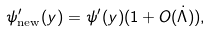Convert formula to latex. <formula><loc_0><loc_0><loc_500><loc_500>\psi ^ { \prime } _ { \text {new} } ( y ) = \psi ^ { \prime } ( y ) ( 1 + O ( \dot { \Lambda } ) ) ,</formula> 